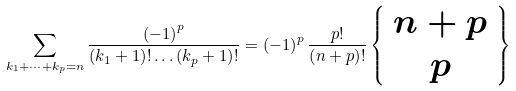Convert formula to latex. <formula><loc_0><loc_0><loc_500><loc_500>\sum _ { k _ { 1 } + \dots + k _ { p } = n } \frac { \left ( - 1 \right ) ^ { p } } { \left ( k _ { 1 } + 1 \right ) ! \dots \left ( k _ { p } + 1 \right ) ! } = \left ( - 1 \right ) ^ { p } \frac { p ! } { \left ( n + p \right ) ! } \left \{ \begin{array} { c } n + p \\ p \end{array} \right \}</formula> 